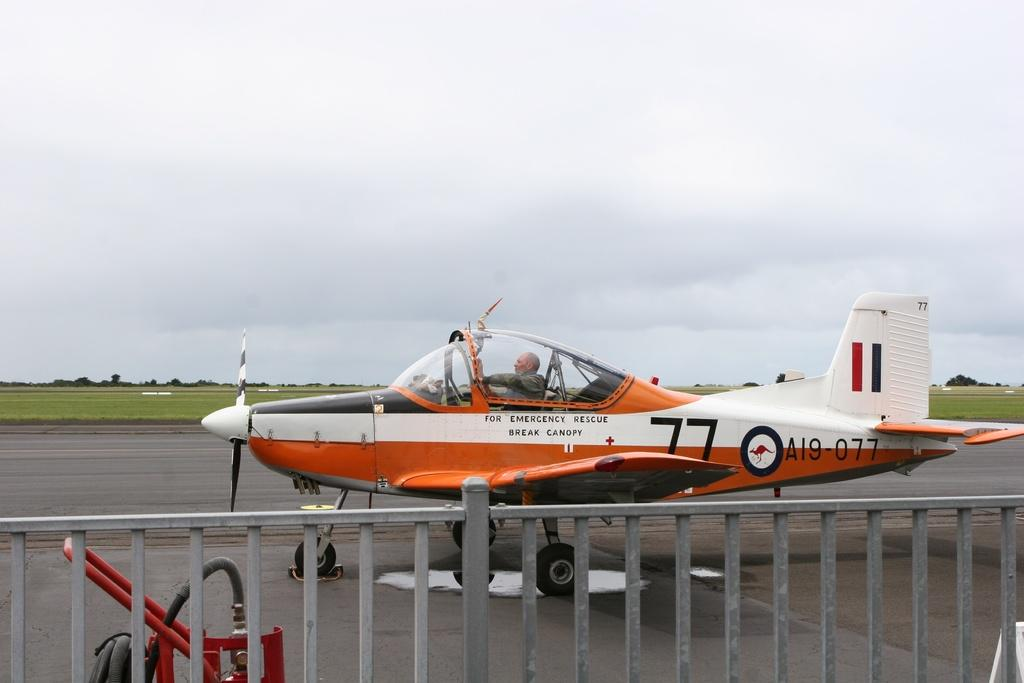<image>
Share a concise interpretation of the image provided. A plane, that is numbered A19 077, is on a runway. 